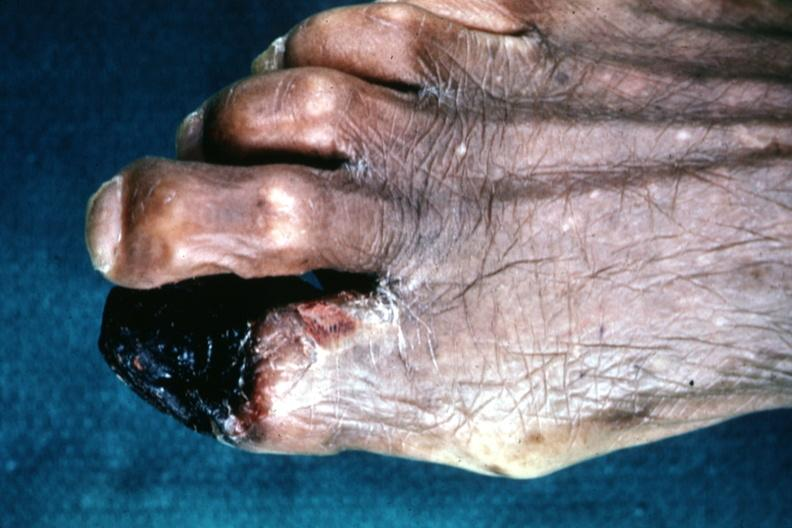what are present?
Answer the question using a single word or phrase. Extremities 